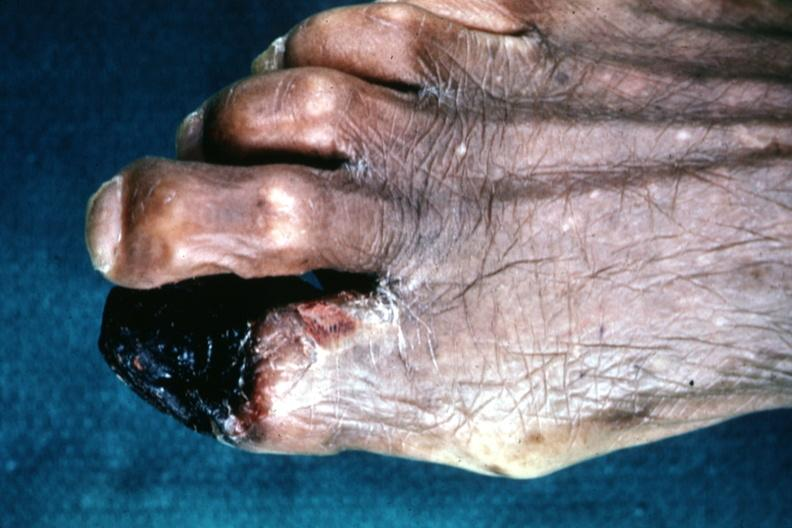what are present?
Answer the question using a single word or phrase. Extremities 